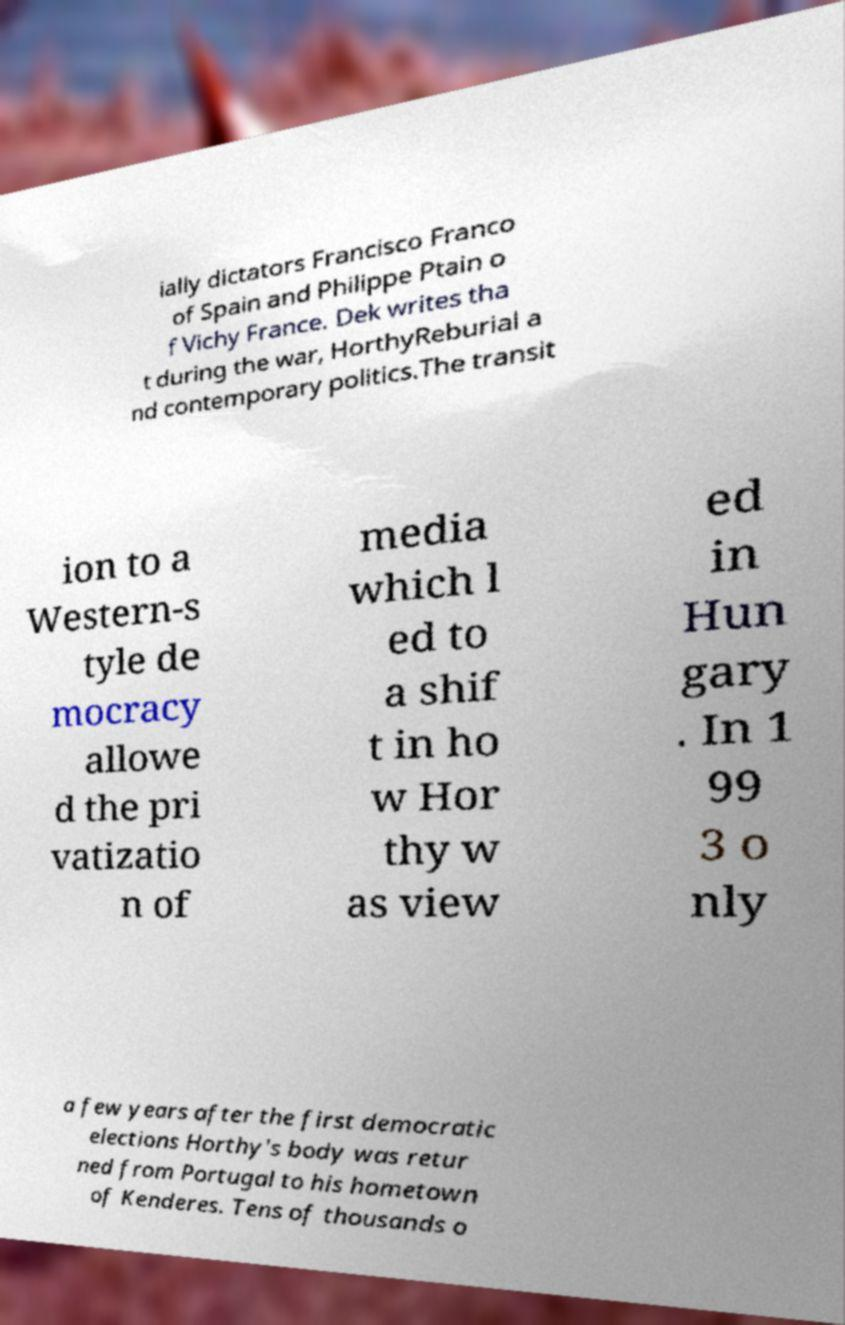Please read and relay the text visible in this image. What does it say? ially dictators Francisco Franco of Spain and Philippe Ptain o f Vichy France. Dek writes tha t during the war, HorthyReburial a nd contemporary politics.The transit ion to a Western-s tyle de mocracy allowe d the pri vatizatio n of media which l ed to a shif t in ho w Hor thy w as view ed in Hun gary . In 1 99 3 o nly a few years after the first democratic elections Horthy's body was retur ned from Portugal to his hometown of Kenderes. Tens of thousands o 